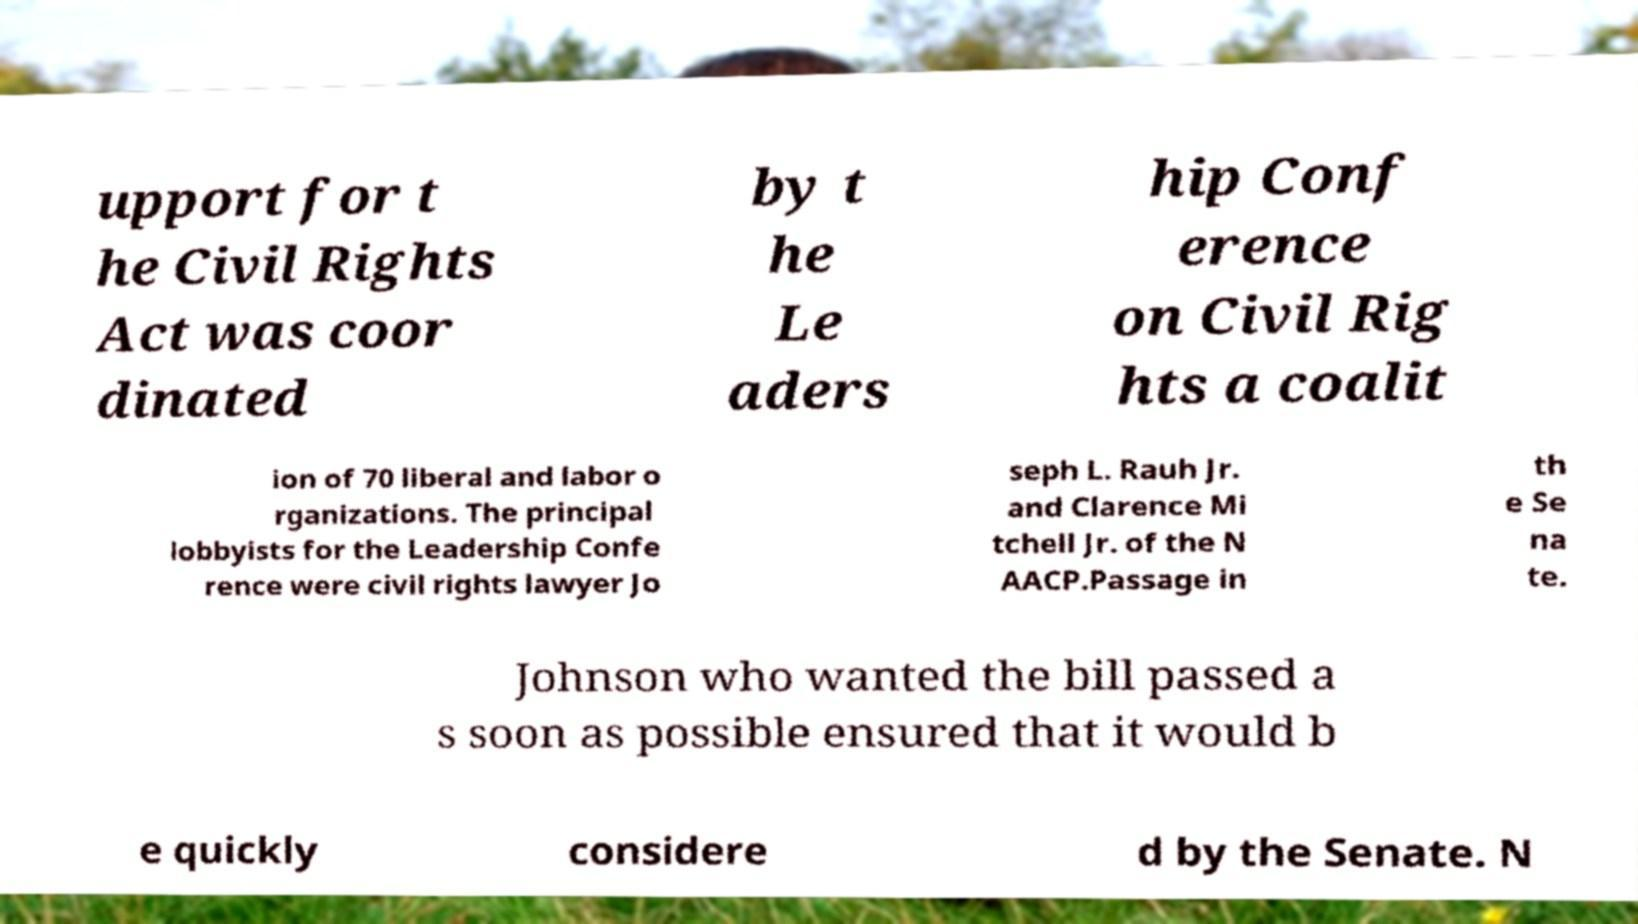Please identify and transcribe the text found in this image. upport for t he Civil Rights Act was coor dinated by t he Le aders hip Conf erence on Civil Rig hts a coalit ion of 70 liberal and labor o rganizations. The principal lobbyists for the Leadership Confe rence were civil rights lawyer Jo seph L. Rauh Jr. and Clarence Mi tchell Jr. of the N AACP.Passage in th e Se na te. Johnson who wanted the bill passed a s soon as possible ensured that it would b e quickly considere d by the Senate. N 